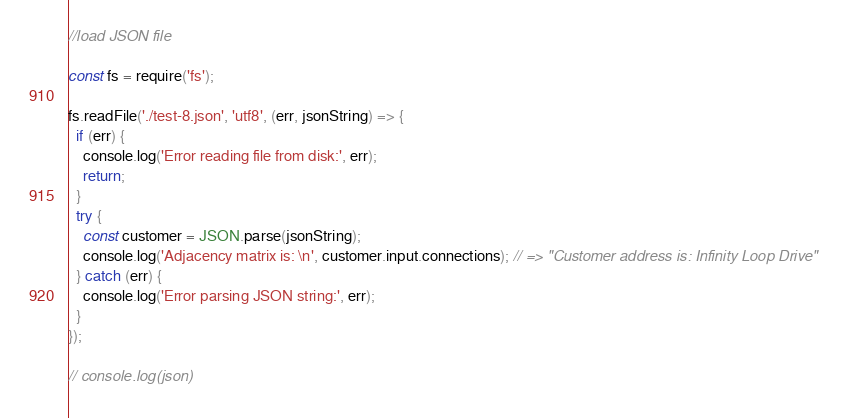<code> <loc_0><loc_0><loc_500><loc_500><_JavaScript_>//load JSON file

const fs = require('fs');

fs.readFile('./test-8.json', 'utf8', (err, jsonString) => {
  if (err) {
    console.log('Error reading file from disk:', err);
    return;
  }
  try {
    const customer = JSON.parse(jsonString);
    console.log('Adjacency matrix is: \n', customer.input.connections); // => "Customer address is: Infinity Loop Drive"
  } catch (err) {
    console.log('Error parsing JSON string:', err);
  }
});

// console.log(json)
</code> 